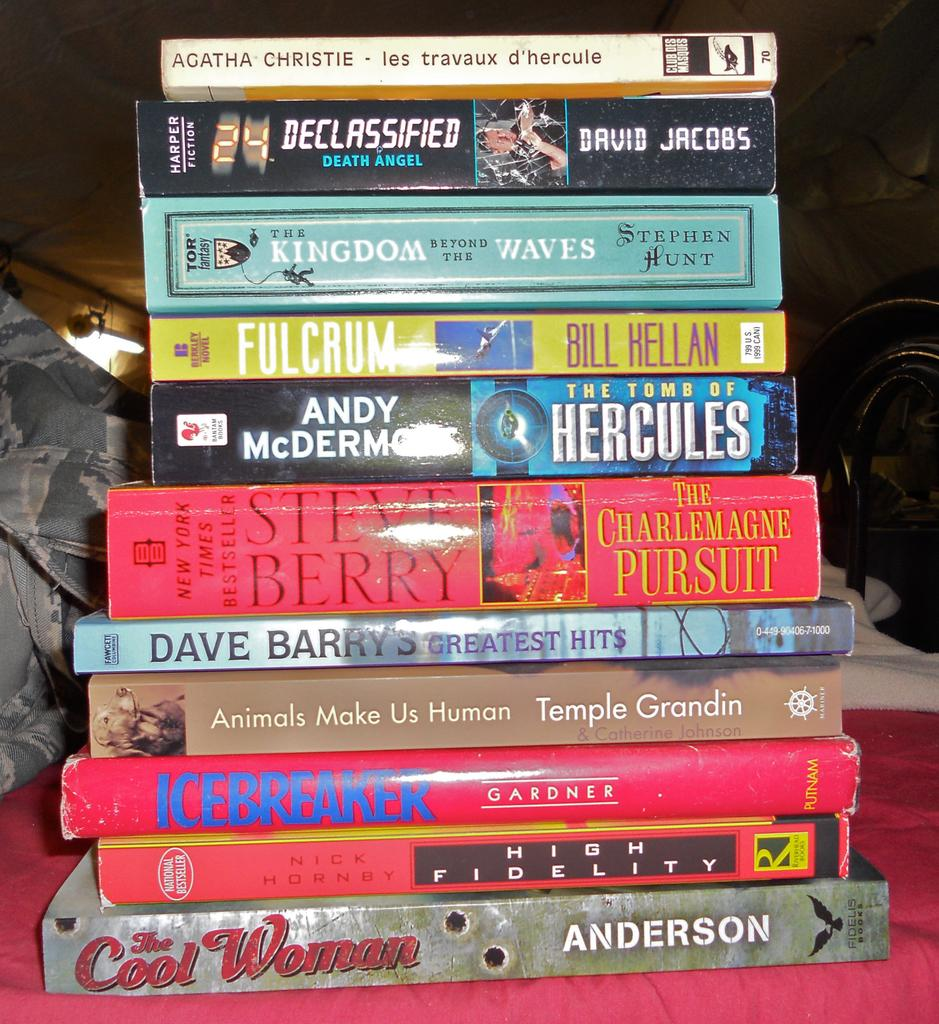<image>
Write a terse but informative summary of the picture. A book by David Jacobs is in the stack titled Declassified Death Angel. 